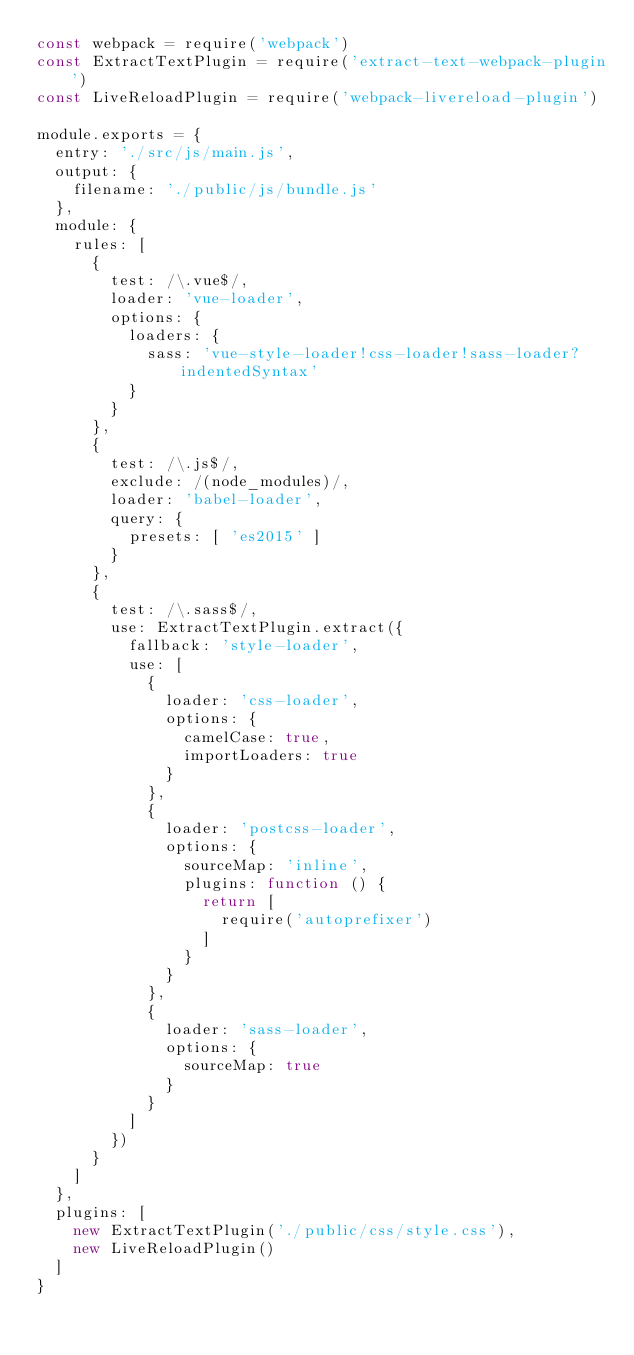<code> <loc_0><loc_0><loc_500><loc_500><_JavaScript_>const webpack = require('webpack')
const ExtractTextPlugin = require('extract-text-webpack-plugin')
const LiveReloadPlugin = require('webpack-livereload-plugin')

module.exports = {
  entry: './src/js/main.js',
  output: {
    filename: './public/js/bundle.js'
  },
  module: {
    rules: [
      {
        test: /\.vue$/,
        loader: 'vue-loader',
        options: {
          loaders: {
            sass: 'vue-style-loader!css-loader!sass-loader?indentedSyntax'
          }
        }
      },
      {
        test: /\.js$/,
        exclude: /(node_modules)/,
        loader: 'babel-loader',
        query: {
          presets: [ 'es2015' ]
        }
      },
      {
        test: /\.sass$/,
        use: ExtractTextPlugin.extract({
          fallback: 'style-loader',
          use: [
            {
              loader: 'css-loader',
              options: {
                camelCase: true,
                importLoaders: true
              }
            },
            {
              loader: 'postcss-loader',
              options: {
                sourceMap: 'inline',
                plugins: function () {
                  return [
                    require('autoprefixer')
                  ]
                }
              }
            },
            {
              loader: 'sass-loader',
              options: {
                sourceMap: true
              }
            }
          ]
        })
      }
    ]
  },
  plugins: [
    new ExtractTextPlugin('./public/css/style.css'),
    new LiveReloadPlugin()
  ]
}

</code> 